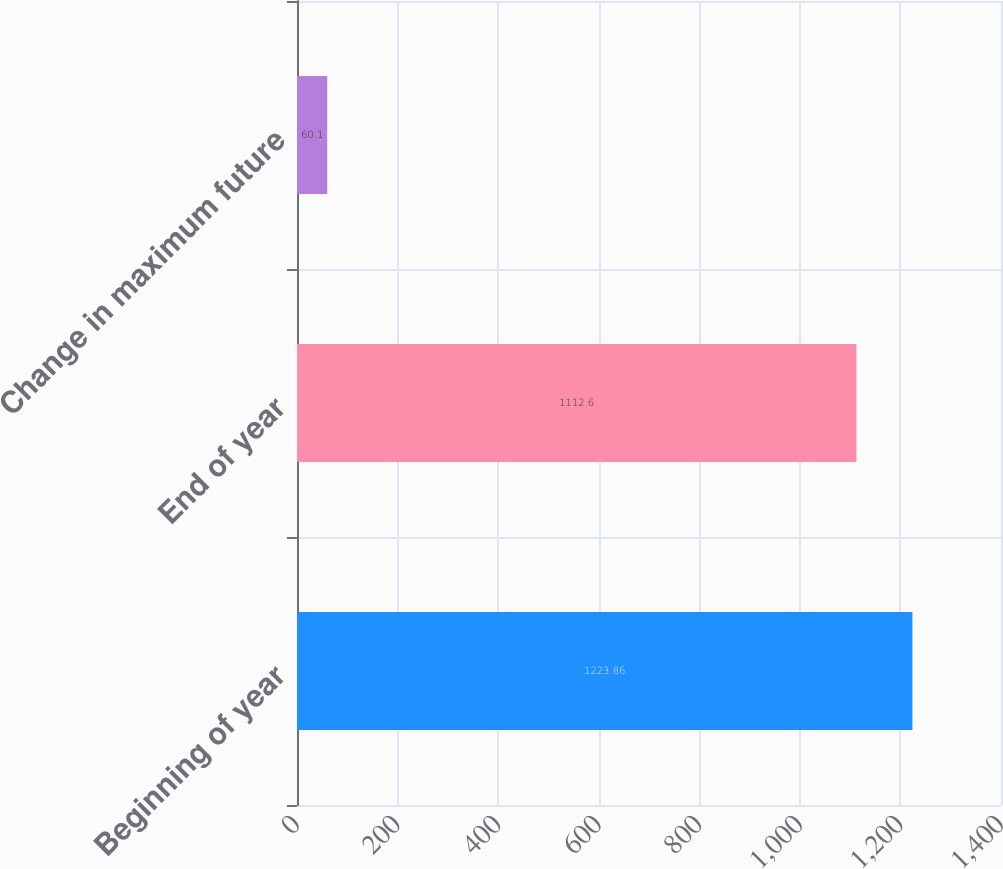<chart> <loc_0><loc_0><loc_500><loc_500><bar_chart><fcel>Beginning of year<fcel>End of year<fcel>Change in maximum future<nl><fcel>1223.86<fcel>1112.6<fcel>60.1<nl></chart> 